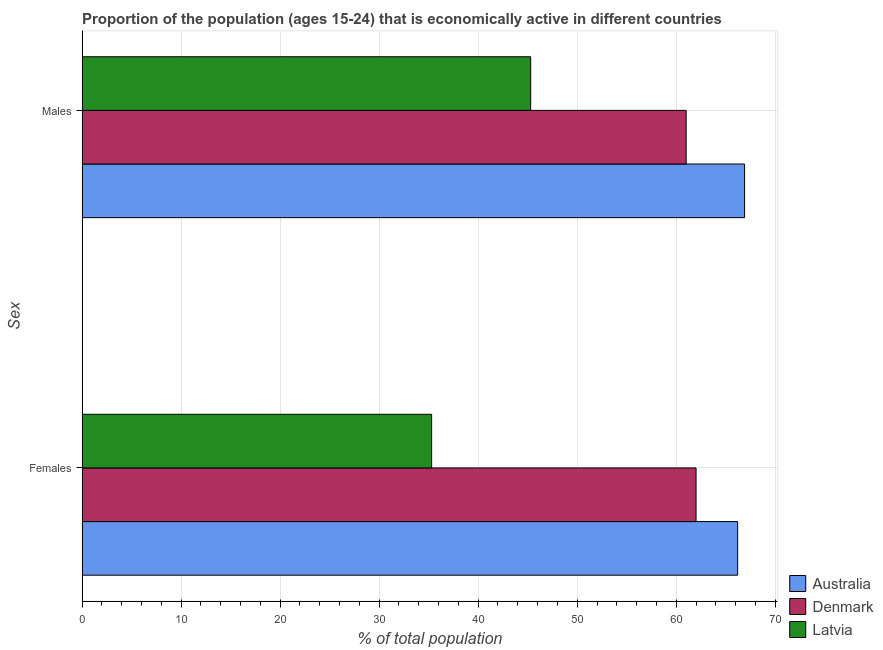Are the number of bars per tick equal to the number of legend labels?
Provide a short and direct response. Yes. How many bars are there on the 1st tick from the bottom?
Provide a succinct answer. 3. What is the label of the 2nd group of bars from the top?
Make the answer very short. Females. Across all countries, what is the maximum percentage of economically active male population?
Offer a terse response. 66.9. Across all countries, what is the minimum percentage of economically active female population?
Provide a short and direct response. 35.3. In which country was the percentage of economically active female population minimum?
Provide a succinct answer. Latvia. What is the total percentage of economically active female population in the graph?
Your answer should be very brief. 163.5. What is the difference between the percentage of economically active female population in Latvia and that in Australia?
Your answer should be compact. -30.9. What is the difference between the percentage of economically active male population in Australia and the percentage of economically active female population in Latvia?
Your answer should be very brief. 31.6. What is the average percentage of economically active female population per country?
Your response must be concise. 54.5. What is the difference between the percentage of economically active male population and percentage of economically active female population in Australia?
Offer a terse response. 0.7. In how many countries, is the percentage of economically active male population greater than 6 %?
Your answer should be very brief. 3. What is the ratio of the percentage of economically active male population in Denmark to that in Latvia?
Make the answer very short. 1.35. In how many countries, is the percentage of economically active male population greater than the average percentage of economically active male population taken over all countries?
Keep it short and to the point. 2. What does the 1st bar from the bottom in Males represents?
Offer a terse response. Australia. Are the values on the major ticks of X-axis written in scientific E-notation?
Your answer should be very brief. No. Does the graph contain any zero values?
Offer a terse response. No. Does the graph contain grids?
Give a very brief answer. Yes. Where does the legend appear in the graph?
Give a very brief answer. Bottom right. How many legend labels are there?
Give a very brief answer. 3. What is the title of the graph?
Offer a very short reply. Proportion of the population (ages 15-24) that is economically active in different countries. What is the label or title of the X-axis?
Offer a very short reply. % of total population. What is the label or title of the Y-axis?
Your answer should be compact. Sex. What is the % of total population in Australia in Females?
Your answer should be very brief. 66.2. What is the % of total population of Denmark in Females?
Provide a short and direct response. 62. What is the % of total population of Latvia in Females?
Offer a very short reply. 35.3. What is the % of total population in Australia in Males?
Provide a succinct answer. 66.9. What is the % of total population of Latvia in Males?
Ensure brevity in your answer.  45.3. Across all Sex, what is the maximum % of total population in Australia?
Offer a terse response. 66.9. Across all Sex, what is the maximum % of total population of Denmark?
Your answer should be very brief. 62. Across all Sex, what is the maximum % of total population in Latvia?
Make the answer very short. 45.3. Across all Sex, what is the minimum % of total population of Australia?
Keep it short and to the point. 66.2. Across all Sex, what is the minimum % of total population in Latvia?
Provide a succinct answer. 35.3. What is the total % of total population in Australia in the graph?
Offer a terse response. 133.1. What is the total % of total population in Denmark in the graph?
Your answer should be compact. 123. What is the total % of total population of Latvia in the graph?
Keep it short and to the point. 80.6. What is the difference between the % of total population in Australia in Females and the % of total population in Latvia in Males?
Offer a terse response. 20.9. What is the difference between the % of total population of Denmark in Females and the % of total population of Latvia in Males?
Give a very brief answer. 16.7. What is the average % of total population of Australia per Sex?
Ensure brevity in your answer.  66.55. What is the average % of total population in Denmark per Sex?
Make the answer very short. 61.5. What is the average % of total population of Latvia per Sex?
Provide a short and direct response. 40.3. What is the difference between the % of total population in Australia and % of total population in Denmark in Females?
Ensure brevity in your answer.  4.2. What is the difference between the % of total population of Australia and % of total population of Latvia in Females?
Offer a very short reply. 30.9. What is the difference between the % of total population of Denmark and % of total population of Latvia in Females?
Offer a terse response. 26.7. What is the difference between the % of total population of Australia and % of total population of Latvia in Males?
Give a very brief answer. 21.6. What is the ratio of the % of total population in Australia in Females to that in Males?
Offer a terse response. 0.99. What is the ratio of the % of total population in Denmark in Females to that in Males?
Keep it short and to the point. 1.02. What is the ratio of the % of total population in Latvia in Females to that in Males?
Make the answer very short. 0.78. What is the difference between the highest and the second highest % of total population in Denmark?
Offer a terse response. 1. What is the difference between the highest and the lowest % of total population in Australia?
Provide a succinct answer. 0.7. 